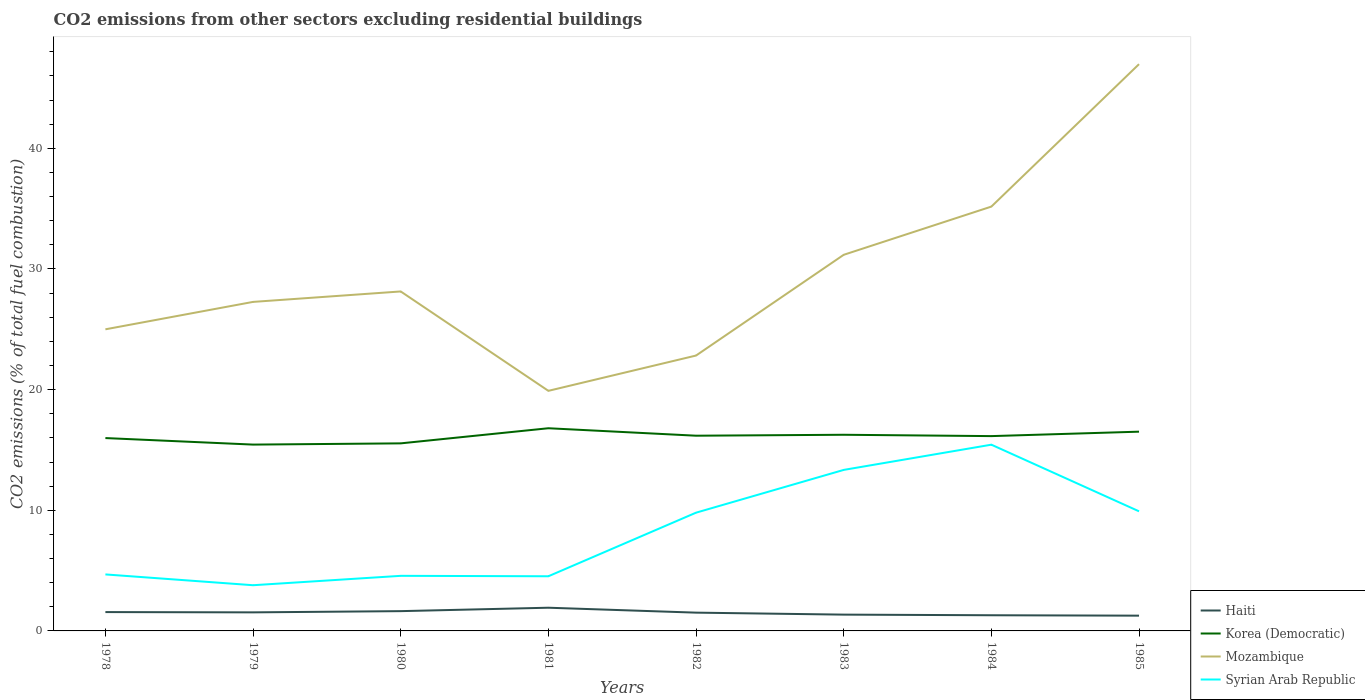How many different coloured lines are there?
Make the answer very short. 4. Across all years, what is the maximum total CO2 emitted in Syrian Arab Republic?
Give a very brief answer. 3.79. In which year was the total CO2 emitted in Korea (Democratic) maximum?
Give a very brief answer. 1979. What is the total total CO2 emitted in Korea (Democratic) in the graph?
Ensure brevity in your answer.  -0.16. What is the difference between the highest and the second highest total CO2 emitted in Korea (Democratic)?
Keep it short and to the point. 1.36. What is the difference between the highest and the lowest total CO2 emitted in Mozambique?
Your answer should be very brief. 3. How many lines are there?
Make the answer very short. 4. What is the difference between two consecutive major ticks on the Y-axis?
Your response must be concise. 10. Does the graph contain any zero values?
Give a very brief answer. No. Does the graph contain grids?
Keep it short and to the point. No. Where does the legend appear in the graph?
Provide a succinct answer. Bottom right. How many legend labels are there?
Your answer should be compact. 4. What is the title of the graph?
Keep it short and to the point. CO2 emissions from other sectors excluding residential buildings. What is the label or title of the X-axis?
Give a very brief answer. Years. What is the label or title of the Y-axis?
Offer a terse response. CO2 emissions (% of total fuel combustion). What is the CO2 emissions (% of total fuel combustion) of Haiti in 1978?
Keep it short and to the point. 1.56. What is the CO2 emissions (% of total fuel combustion) in Korea (Democratic) in 1978?
Offer a terse response. 15.99. What is the CO2 emissions (% of total fuel combustion) of Syrian Arab Republic in 1978?
Make the answer very short. 4.68. What is the CO2 emissions (% of total fuel combustion) in Haiti in 1979?
Make the answer very short. 1.54. What is the CO2 emissions (% of total fuel combustion) in Korea (Democratic) in 1979?
Your answer should be very brief. 15.44. What is the CO2 emissions (% of total fuel combustion) in Mozambique in 1979?
Offer a terse response. 27.27. What is the CO2 emissions (% of total fuel combustion) of Syrian Arab Republic in 1979?
Your response must be concise. 3.79. What is the CO2 emissions (% of total fuel combustion) of Haiti in 1980?
Keep it short and to the point. 1.64. What is the CO2 emissions (% of total fuel combustion) of Korea (Democratic) in 1980?
Your answer should be very brief. 15.55. What is the CO2 emissions (% of total fuel combustion) in Mozambique in 1980?
Provide a succinct answer. 28.14. What is the CO2 emissions (% of total fuel combustion) of Syrian Arab Republic in 1980?
Offer a terse response. 4.57. What is the CO2 emissions (% of total fuel combustion) of Haiti in 1981?
Your answer should be very brief. 1.92. What is the CO2 emissions (% of total fuel combustion) in Korea (Democratic) in 1981?
Your answer should be very brief. 16.8. What is the CO2 emissions (% of total fuel combustion) of Mozambique in 1981?
Give a very brief answer. 19.9. What is the CO2 emissions (% of total fuel combustion) of Syrian Arab Republic in 1981?
Your response must be concise. 4.53. What is the CO2 emissions (% of total fuel combustion) in Haiti in 1982?
Keep it short and to the point. 1.52. What is the CO2 emissions (% of total fuel combustion) of Korea (Democratic) in 1982?
Provide a short and direct response. 16.18. What is the CO2 emissions (% of total fuel combustion) in Mozambique in 1982?
Give a very brief answer. 22.83. What is the CO2 emissions (% of total fuel combustion) of Syrian Arab Republic in 1982?
Offer a terse response. 9.8. What is the CO2 emissions (% of total fuel combustion) in Haiti in 1983?
Keep it short and to the point. 1.35. What is the CO2 emissions (% of total fuel combustion) of Korea (Democratic) in 1983?
Make the answer very short. 16.26. What is the CO2 emissions (% of total fuel combustion) of Mozambique in 1983?
Your answer should be compact. 31.18. What is the CO2 emissions (% of total fuel combustion) of Syrian Arab Republic in 1983?
Offer a terse response. 13.35. What is the CO2 emissions (% of total fuel combustion) of Haiti in 1984?
Provide a succinct answer. 1.3. What is the CO2 emissions (% of total fuel combustion) of Korea (Democratic) in 1984?
Ensure brevity in your answer.  16.15. What is the CO2 emissions (% of total fuel combustion) of Mozambique in 1984?
Offer a very short reply. 35.17. What is the CO2 emissions (% of total fuel combustion) of Syrian Arab Republic in 1984?
Give a very brief answer. 15.44. What is the CO2 emissions (% of total fuel combustion) in Haiti in 1985?
Ensure brevity in your answer.  1.27. What is the CO2 emissions (% of total fuel combustion) of Korea (Democratic) in 1985?
Keep it short and to the point. 16.52. What is the CO2 emissions (% of total fuel combustion) of Mozambique in 1985?
Offer a terse response. 46.98. What is the CO2 emissions (% of total fuel combustion) of Syrian Arab Republic in 1985?
Keep it short and to the point. 9.91. Across all years, what is the maximum CO2 emissions (% of total fuel combustion) in Haiti?
Your answer should be very brief. 1.92. Across all years, what is the maximum CO2 emissions (% of total fuel combustion) of Korea (Democratic)?
Provide a short and direct response. 16.8. Across all years, what is the maximum CO2 emissions (% of total fuel combustion) in Mozambique?
Provide a short and direct response. 46.98. Across all years, what is the maximum CO2 emissions (% of total fuel combustion) in Syrian Arab Republic?
Offer a very short reply. 15.44. Across all years, what is the minimum CO2 emissions (% of total fuel combustion) in Haiti?
Your answer should be very brief. 1.27. Across all years, what is the minimum CO2 emissions (% of total fuel combustion) of Korea (Democratic)?
Your response must be concise. 15.44. Across all years, what is the minimum CO2 emissions (% of total fuel combustion) of Mozambique?
Your response must be concise. 19.9. Across all years, what is the minimum CO2 emissions (% of total fuel combustion) of Syrian Arab Republic?
Give a very brief answer. 3.79. What is the total CO2 emissions (% of total fuel combustion) of Haiti in the graph?
Give a very brief answer. 12.09. What is the total CO2 emissions (% of total fuel combustion) of Korea (Democratic) in the graph?
Offer a terse response. 128.88. What is the total CO2 emissions (% of total fuel combustion) of Mozambique in the graph?
Offer a very short reply. 236.47. What is the total CO2 emissions (% of total fuel combustion) in Syrian Arab Republic in the graph?
Keep it short and to the point. 66.07. What is the difference between the CO2 emissions (% of total fuel combustion) in Haiti in 1978 and that in 1979?
Give a very brief answer. 0.02. What is the difference between the CO2 emissions (% of total fuel combustion) of Korea (Democratic) in 1978 and that in 1979?
Keep it short and to the point. 0.54. What is the difference between the CO2 emissions (% of total fuel combustion) in Mozambique in 1978 and that in 1979?
Offer a terse response. -2.27. What is the difference between the CO2 emissions (% of total fuel combustion) of Syrian Arab Republic in 1978 and that in 1979?
Offer a very short reply. 0.9. What is the difference between the CO2 emissions (% of total fuel combustion) of Haiti in 1978 and that in 1980?
Give a very brief answer. -0.08. What is the difference between the CO2 emissions (% of total fuel combustion) in Korea (Democratic) in 1978 and that in 1980?
Ensure brevity in your answer.  0.44. What is the difference between the CO2 emissions (% of total fuel combustion) in Mozambique in 1978 and that in 1980?
Offer a terse response. -3.14. What is the difference between the CO2 emissions (% of total fuel combustion) of Syrian Arab Republic in 1978 and that in 1980?
Offer a very short reply. 0.12. What is the difference between the CO2 emissions (% of total fuel combustion) in Haiti in 1978 and that in 1981?
Provide a short and direct response. -0.36. What is the difference between the CO2 emissions (% of total fuel combustion) in Korea (Democratic) in 1978 and that in 1981?
Give a very brief answer. -0.81. What is the difference between the CO2 emissions (% of total fuel combustion) of Mozambique in 1978 and that in 1981?
Offer a very short reply. 5.1. What is the difference between the CO2 emissions (% of total fuel combustion) in Syrian Arab Republic in 1978 and that in 1981?
Offer a very short reply. 0.15. What is the difference between the CO2 emissions (% of total fuel combustion) of Haiti in 1978 and that in 1982?
Ensure brevity in your answer.  0.05. What is the difference between the CO2 emissions (% of total fuel combustion) in Korea (Democratic) in 1978 and that in 1982?
Provide a succinct answer. -0.2. What is the difference between the CO2 emissions (% of total fuel combustion) in Mozambique in 1978 and that in 1982?
Provide a succinct answer. 2.17. What is the difference between the CO2 emissions (% of total fuel combustion) in Syrian Arab Republic in 1978 and that in 1982?
Your answer should be compact. -5.12. What is the difference between the CO2 emissions (% of total fuel combustion) in Haiti in 1978 and that in 1983?
Offer a very short reply. 0.21. What is the difference between the CO2 emissions (% of total fuel combustion) of Korea (Democratic) in 1978 and that in 1983?
Offer a terse response. -0.27. What is the difference between the CO2 emissions (% of total fuel combustion) of Mozambique in 1978 and that in 1983?
Keep it short and to the point. -6.18. What is the difference between the CO2 emissions (% of total fuel combustion) in Syrian Arab Republic in 1978 and that in 1983?
Your answer should be compact. -8.66. What is the difference between the CO2 emissions (% of total fuel combustion) of Haiti in 1978 and that in 1984?
Your answer should be compact. 0.26. What is the difference between the CO2 emissions (% of total fuel combustion) in Korea (Democratic) in 1978 and that in 1984?
Offer a very short reply. -0.16. What is the difference between the CO2 emissions (% of total fuel combustion) in Mozambique in 1978 and that in 1984?
Your answer should be very brief. -10.17. What is the difference between the CO2 emissions (% of total fuel combustion) of Syrian Arab Republic in 1978 and that in 1984?
Offer a terse response. -10.75. What is the difference between the CO2 emissions (% of total fuel combustion) of Haiti in 1978 and that in 1985?
Make the answer very short. 0.3. What is the difference between the CO2 emissions (% of total fuel combustion) in Korea (Democratic) in 1978 and that in 1985?
Ensure brevity in your answer.  -0.53. What is the difference between the CO2 emissions (% of total fuel combustion) in Mozambique in 1978 and that in 1985?
Provide a succinct answer. -21.98. What is the difference between the CO2 emissions (% of total fuel combustion) in Syrian Arab Republic in 1978 and that in 1985?
Offer a very short reply. -5.23. What is the difference between the CO2 emissions (% of total fuel combustion) of Haiti in 1979 and that in 1980?
Make the answer very short. -0.1. What is the difference between the CO2 emissions (% of total fuel combustion) in Korea (Democratic) in 1979 and that in 1980?
Make the answer very short. -0.1. What is the difference between the CO2 emissions (% of total fuel combustion) of Mozambique in 1979 and that in 1980?
Your answer should be compact. -0.87. What is the difference between the CO2 emissions (% of total fuel combustion) in Syrian Arab Republic in 1979 and that in 1980?
Keep it short and to the point. -0.78. What is the difference between the CO2 emissions (% of total fuel combustion) of Haiti in 1979 and that in 1981?
Give a very brief answer. -0.38. What is the difference between the CO2 emissions (% of total fuel combustion) in Korea (Democratic) in 1979 and that in 1981?
Provide a succinct answer. -1.36. What is the difference between the CO2 emissions (% of total fuel combustion) of Mozambique in 1979 and that in 1981?
Your answer should be very brief. 7.37. What is the difference between the CO2 emissions (% of total fuel combustion) in Syrian Arab Republic in 1979 and that in 1981?
Offer a terse response. -0.74. What is the difference between the CO2 emissions (% of total fuel combustion) in Haiti in 1979 and that in 1982?
Offer a very short reply. 0.02. What is the difference between the CO2 emissions (% of total fuel combustion) of Korea (Democratic) in 1979 and that in 1982?
Make the answer very short. -0.74. What is the difference between the CO2 emissions (% of total fuel combustion) of Mozambique in 1979 and that in 1982?
Offer a terse response. 4.45. What is the difference between the CO2 emissions (% of total fuel combustion) in Syrian Arab Republic in 1979 and that in 1982?
Give a very brief answer. -6.01. What is the difference between the CO2 emissions (% of total fuel combustion) of Haiti in 1979 and that in 1983?
Provide a succinct answer. 0.19. What is the difference between the CO2 emissions (% of total fuel combustion) in Korea (Democratic) in 1979 and that in 1983?
Offer a very short reply. -0.82. What is the difference between the CO2 emissions (% of total fuel combustion) of Mozambique in 1979 and that in 1983?
Make the answer very short. -3.9. What is the difference between the CO2 emissions (% of total fuel combustion) of Syrian Arab Republic in 1979 and that in 1983?
Your answer should be very brief. -9.56. What is the difference between the CO2 emissions (% of total fuel combustion) of Haiti in 1979 and that in 1984?
Offer a terse response. 0.24. What is the difference between the CO2 emissions (% of total fuel combustion) in Korea (Democratic) in 1979 and that in 1984?
Make the answer very short. -0.7. What is the difference between the CO2 emissions (% of total fuel combustion) of Mozambique in 1979 and that in 1984?
Keep it short and to the point. -7.9. What is the difference between the CO2 emissions (% of total fuel combustion) of Syrian Arab Republic in 1979 and that in 1984?
Offer a very short reply. -11.65. What is the difference between the CO2 emissions (% of total fuel combustion) in Haiti in 1979 and that in 1985?
Offer a terse response. 0.27. What is the difference between the CO2 emissions (% of total fuel combustion) in Korea (Democratic) in 1979 and that in 1985?
Provide a succinct answer. -1.07. What is the difference between the CO2 emissions (% of total fuel combustion) in Mozambique in 1979 and that in 1985?
Offer a terse response. -19.71. What is the difference between the CO2 emissions (% of total fuel combustion) of Syrian Arab Republic in 1979 and that in 1985?
Offer a terse response. -6.13. What is the difference between the CO2 emissions (% of total fuel combustion) in Haiti in 1980 and that in 1981?
Make the answer very short. -0.28. What is the difference between the CO2 emissions (% of total fuel combustion) in Korea (Democratic) in 1980 and that in 1981?
Make the answer very short. -1.25. What is the difference between the CO2 emissions (% of total fuel combustion) in Mozambique in 1980 and that in 1981?
Ensure brevity in your answer.  8.24. What is the difference between the CO2 emissions (% of total fuel combustion) in Syrian Arab Republic in 1980 and that in 1981?
Keep it short and to the point. 0.04. What is the difference between the CO2 emissions (% of total fuel combustion) of Haiti in 1980 and that in 1982?
Make the answer very short. 0.12. What is the difference between the CO2 emissions (% of total fuel combustion) of Korea (Democratic) in 1980 and that in 1982?
Give a very brief answer. -0.63. What is the difference between the CO2 emissions (% of total fuel combustion) in Mozambique in 1980 and that in 1982?
Your answer should be very brief. 5.31. What is the difference between the CO2 emissions (% of total fuel combustion) of Syrian Arab Republic in 1980 and that in 1982?
Make the answer very short. -5.24. What is the difference between the CO2 emissions (% of total fuel combustion) of Haiti in 1980 and that in 1983?
Your answer should be very brief. 0.29. What is the difference between the CO2 emissions (% of total fuel combustion) in Korea (Democratic) in 1980 and that in 1983?
Provide a succinct answer. -0.71. What is the difference between the CO2 emissions (% of total fuel combustion) in Mozambique in 1980 and that in 1983?
Your answer should be compact. -3.04. What is the difference between the CO2 emissions (% of total fuel combustion) of Syrian Arab Republic in 1980 and that in 1983?
Provide a succinct answer. -8.78. What is the difference between the CO2 emissions (% of total fuel combustion) of Haiti in 1980 and that in 1984?
Offer a terse response. 0.34. What is the difference between the CO2 emissions (% of total fuel combustion) in Korea (Democratic) in 1980 and that in 1984?
Offer a terse response. -0.6. What is the difference between the CO2 emissions (% of total fuel combustion) of Mozambique in 1980 and that in 1984?
Your answer should be very brief. -7.03. What is the difference between the CO2 emissions (% of total fuel combustion) in Syrian Arab Republic in 1980 and that in 1984?
Give a very brief answer. -10.87. What is the difference between the CO2 emissions (% of total fuel combustion) in Haiti in 1980 and that in 1985?
Your response must be concise. 0.37. What is the difference between the CO2 emissions (% of total fuel combustion) of Korea (Democratic) in 1980 and that in 1985?
Give a very brief answer. -0.97. What is the difference between the CO2 emissions (% of total fuel combustion) in Mozambique in 1980 and that in 1985?
Keep it short and to the point. -18.84. What is the difference between the CO2 emissions (% of total fuel combustion) of Syrian Arab Republic in 1980 and that in 1985?
Offer a very short reply. -5.35. What is the difference between the CO2 emissions (% of total fuel combustion) in Haiti in 1981 and that in 1982?
Give a very brief answer. 0.41. What is the difference between the CO2 emissions (% of total fuel combustion) in Korea (Democratic) in 1981 and that in 1982?
Offer a terse response. 0.62. What is the difference between the CO2 emissions (% of total fuel combustion) in Mozambique in 1981 and that in 1982?
Offer a terse response. -2.93. What is the difference between the CO2 emissions (% of total fuel combustion) of Syrian Arab Republic in 1981 and that in 1982?
Give a very brief answer. -5.27. What is the difference between the CO2 emissions (% of total fuel combustion) of Haiti in 1981 and that in 1983?
Provide a succinct answer. 0.57. What is the difference between the CO2 emissions (% of total fuel combustion) in Korea (Democratic) in 1981 and that in 1983?
Provide a succinct answer. 0.54. What is the difference between the CO2 emissions (% of total fuel combustion) in Mozambique in 1981 and that in 1983?
Offer a terse response. -11.28. What is the difference between the CO2 emissions (% of total fuel combustion) in Syrian Arab Republic in 1981 and that in 1983?
Provide a short and direct response. -8.82. What is the difference between the CO2 emissions (% of total fuel combustion) of Haiti in 1981 and that in 1984?
Give a very brief answer. 0.62. What is the difference between the CO2 emissions (% of total fuel combustion) in Korea (Democratic) in 1981 and that in 1984?
Offer a very short reply. 0.65. What is the difference between the CO2 emissions (% of total fuel combustion) of Mozambique in 1981 and that in 1984?
Your answer should be very brief. -15.27. What is the difference between the CO2 emissions (% of total fuel combustion) of Syrian Arab Republic in 1981 and that in 1984?
Your answer should be very brief. -10.91. What is the difference between the CO2 emissions (% of total fuel combustion) of Haiti in 1981 and that in 1985?
Offer a terse response. 0.66. What is the difference between the CO2 emissions (% of total fuel combustion) of Korea (Democratic) in 1981 and that in 1985?
Your answer should be compact. 0.28. What is the difference between the CO2 emissions (% of total fuel combustion) of Mozambique in 1981 and that in 1985?
Provide a succinct answer. -27.08. What is the difference between the CO2 emissions (% of total fuel combustion) of Syrian Arab Republic in 1981 and that in 1985?
Offer a terse response. -5.38. What is the difference between the CO2 emissions (% of total fuel combustion) in Haiti in 1982 and that in 1983?
Offer a very short reply. 0.16. What is the difference between the CO2 emissions (% of total fuel combustion) of Korea (Democratic) in 1982 and that in 1983?
Ensure brevity in your answer.  -0.08. What is the difference between the CO2 emissions (% of total fuel combustion) in Mozambique in 1982 and that in 1983?
Provide a short and direct response. -8.35. What is the difference between the CO2 emissions (% of total fuel combustion) in Syrian Arab Republic in 1982 and that in 1983?
Give a very brief answer. -3.54. What is the difference between the CO2 emissions (% of total fuel combustion) of Haiti in 1982 and that in 1984?
Give a very brief answer. 0.22. What is the difference between the CO2 emissions (% of total fuel combustion) in Korea (Democratic) in 1982 and that in 1984?
Offer a terse response. 0.03. What is the difference between the CO2 emissions (% of total fuel combustion) of Mozambique in 1982 and that in 1984?
Ensure brevity in your answer.  -12.35. What is the difference between the CO2 emissions (% of total fuel combustion) of Syrian Arab Republic in 1982 and that in 1984?
Offer a terse response. -5.64. What is the difference between the CO2 emissions (% of total fuel combustion) in Haiti in 1982 and that in 1985?
Your response must be concise. 0.25. What is the difference between the CO2 emissions (% of total fuel combustion) in Korea (Democratic) in 1982 and that in 1985?
Provide a succinct answer. -0.33. What is the difference between the CO2 emissions (% of total fuel combustion) in Mozambique in 1982 and that in 1985?
Provide a succinct answer. -24.15. What is the difference between the CO2 emissions (% of total fuel combustion) in Syrian Arab Republic in 1982 and that in 1985?
Provide a succinct answer. -0.11. What is the difference between the CO2 emissions (% of total fuel combustion) in Haiti in 1983 and that in 1984?
Ensure brevity in your answer.  0.05. What is the difference between the CO2 emissions (% of total fuel combustion) of Korea (Democratic) in 1983 and that in 1984?
Keep it short and to the point. 0.11. What is the difference between the CO2 emissions (% of total fuel combustion) in Mozambique in 1983 and that in 1984?
Keep it short and to the point. -4. What is the difference between the CO2 emissions (% of total fuel combustion) in Syrian Arab Republic in 1983 and that in 1984?
Keep it short and to the point. -2.09. What is the difference between the CO2 emissions (% of total fuel combustion) of Haiti in 1983 and that in 1985?
Offer a terse response. 0.09. What is the difference between the CO2 emissions (% of total fuel combustion) of Korea (Democratic) in 1983 and that in 1985?
Your response must be concise. -0.26. What is the difference between the CO2 emissions (% of total fuel combustion) in Mozambique in 1983 and that in 1985?
Provide a succinct answer. -15.8. What is the difference between the CO2 emissions (% of total fuel combustion) of Syrian Arab Republic in 1983 and that in 1985?
Provide a succinct answer. 3.43. What is the difference between the CO2 emissions (% of total fuel combustion) of Haiti in 1984 and that in 1985?
Keep it short and to the point. 0.03. What is the difference between the CO2 emissions (% of total fuel combustion) of Korea (Democratic) in 1984 and that in 1985?
Keep it short and to the point. -0.37. What is the difference between the CO2 emissions (% of total fuel combustion) of Mozambique in 1984 and that in 1985?
Provide a succinct answer. -11.81. What is the difference between the CO2 emissions (% of total fuel combustion) in Syrian Arab Republic in 1984 and that in 1985?
Your answer should be compact. 5.52. What is the difference between the CO2 emissions (% of total fuel combustion) of Haiti in 1978 and the CO2 emissions (% of total fuel combustion) of Korea (Democratic) in 1979?
Give a very brief answer. -13.88. What is the difference between the CO2 emissions (% of total fuel combustion) of Haiti in 1978 and the CO2 emissions (% of total fuel combustion) of Mozambique in 1979?
Your response must be concise. -25.71. What is the difference between the CO2 emissions (% of total fuel combustion) in Haiti in 1978 and the CO2 emissions (% of total fuel combustion) in Syrian Arab Republic in 1979?
Give a very brief answer. -2.23. What is the difference between the CO2 emissions (% of total fuel combustion) of Korea (Democratic) in 1978 and the CO2 emissions (% of total fuel combustion) of Mozambique in 1979?
Your answer should be compact. -11.29. What is the difference between the CO2 emissions (% of total fuel combustion) of Korea (Democratic) in 1978 and the CO2 emissions (% of total fuel combustion) of Syrian Arab Republic in 1979?
Offer a very short reply. 12.2. What is the difference between the CO2 emissions (% of total fuel combustion) in Mozambique in 1978 and the CO2 emissions (% of total fuel combustion) in Syrian Arab Republic in 1979?
Offer a terse response. 21.21. What is the difference between the CO2 emissions (% of total fuel combustion) in Haiti in 1978 and the CO2 emissions (% of total fuel combustion) in Korea (Democratic) in 1980?
Ensure brevity in your answer.  -13.98. What is the difference between the CO2 emissions (% of total fuel combustion) in Haiti in 1978 and the CO2 emissions (% of total fuel combustion) in Mozambique in 1980?
Your response must be concise. -26.58. What is the difference between the CO2 emissions (% of total fuel combustion) of Haiti in 1978 and the CO2 emissions (% of total fuel combustion) of Syrian Arab Republic in 1980?
Give a very brief answer. -3. What is the difference between the CO2 emissions (% of total fuel combustion) in Korea (Democratic) in 1978 and the CO2 emissions (% of total fuel combustion) in Mozambique in 1980?
Provide a succinct answer. -12.15. What is the difference between the CO2 emissions (% of total fuel combustion) of Korea (Democratic) in 1978 and the CO2 emissions (% of total fuel combustion) of Syrian Arab Republic in 1980?
Keep it short and to the point. 11.42. What is the difference between the CO2 emissions (% of total fuel combustion) in Mozambique in 1978 and the CO2 emissions (% of total fuel combustion) in Syrian Arab Republic in 1980?
Give a very brief answer. 20.43. What is the difference between the CO2 emissions (% of total fuel combustion) of Haiti in 1978 and the CO2 emissions (% of total fuel combustion) of Korea (Democratic) in 1981?
Your answer should be compact. -15.24. What is the difference between the CO2 emissions (% of total fuel combustion) of Haiti in 1978 and the CO2 emissions (% of total fuel combustion) of Mozambique in 1981?
Offer a terse response. -18.34. What is the difference between the CO2 emissions (% of total fuel combustion) in Haiti in 1978 and the CO2 emissions (% of total fuel combustion) in Syrian Arab Republic in 1981?
Your response must be concise. -2.97. What is the difference between the CO2 emissions (% of total fuel combustion) in Korea (Democratic) in 1978 and the CO2 emissions (% of total fuel combustion) in Mozambique in 1981?
Provide a succinct answer. -3.91. What is the difference between the CO2 emissions (% of total fuel combustion) in Korea (Democratic) in 1978 and the CO2 emissions (% of total fuel combustion) in Syrian Arab Republic in 1981?
Your answer should be compact. 11.46. What is the difference between the CO2 emissions (% of total fuel combustion) in Mozambique in 1978 and the CO2 emissions (% of total fuel combustion) in Syrian Arab Republic in 1981?
Provide a short and direct response. 20.47. What is the difference between the CO2 emissions (% of total fuel combustion) in Haiti in 1978 and the CO2 emissions (% of total fuel combustion) in Korea (Democratic) in 1982?
Offer a very short reply. -14.62. What is the difference between the CO2 emissions (% of total fuel combustion) in Haiti in 1978 and the CO2 emissions (% of total fuel combustion) in Mozambique in 1982?
Your answer should be compact. -21.26. What is the difference between the CO2 emissions (% of total fuel combustion) of Haiti in 1978 and the CO2 emissions (% of total fuel combustion) of Syrian Arab Republic in 1982?
Your answer should be compact. -8.24. What is the difference between the CO2 emissions (% of total fuel combustion) of Korea (Democratic) in 1978 and the CO2 emissions (% of total fuel combustion) of Mozambique in 1982?
Your answer should be very brief. -6.84. What is the difference between the CO2 emissions (% of total fuel combustion) of Korea (Democratic) in 1978 and the CO2 emissions (% of total fuel combustion) of Syrian Arab Republic in 1982?
Offer a terse response. 6.18. What is the difference between the CO2 emissions (% of total fuel combustion) of Mozambique in 1978 and the CO2 emissions (% of total fuel combustion) of Syrian Arab Republic in 1982?
Ensure brevity in your answer.  15.2. What is the difference between the CO2 emissions (% of total fuel combustion) in Haiti in 1978 and the CO2 emissions (% of total fuel combustion) in Korea (Democratic) in 1983?
Give a very brief answer. -14.7. What is the difference between the CO2 emissions (% of total fuel combustion) of Haiti in 1978 and the CO2 emissions (% of total fuel combustion) of Mozambique in 1983?
Your answer should be very brief. -29.61. What is the difference between the CO2 emissions (% of total fuel combustion) in Haiti in 1978 and the CO2 emissions (% of total fuel combustion) in Syrian Arab Republic in 1983?
Give a very brief answer. -11.78. What is the difference between the CO2 emissions (% of total fuel combustion) of Korea (Democratic) in 1978 and the CO2 emissions (% of total fuel combustion) of Mozambique in 1983?
Offer a very short reply. -15.19. What is the difference between the CO2 emissions (% of total fuel combustion) of Korea (Democratic) in 1978 and the CO2 emissions (% of total fuel combustion) of Syrian Arab Republic in 1983?
Provide a succinct answer. 2.64. What is the difference between the CO2 emissions (% of total fuel combustion) of Mozambique in 1978 and the CO2 emissions (% of total fuel combustion) of Syrian Arab Republic in 1983?
Your response must be concise. 11.65. What is the difference between the CO2 emissions (% of total fuel combustion) in Haiti in 1978 and the CO2 emissions (% of total fuel combustion) in Korea (Democratic) in 1984?
Ensure brevity in your answer.  -14.59. What is the difference between the CO2 emissions (% of total fuel combustion) in Haiti in 1978 and the CO2 emissions (% of total fuel combustion) in Mozambique in 1984?
Your response must be concise. -33.61. What is the difference between the CO2 emissions (% of total fuel combustion) in Haiti in 1978 and the CO2 emissions (% of total fuel combustion) in Syrian Arab Republic in 1984?
Ensure brevity in your answer.  -13.87. What is the difference between the CO2 emissions (% of total fuel combustion) of Korea (Democratic) in 1978 and the CO2 emissions (% of total fuel combustion) of Mozambique in 1984?
Make the answer very short. -19.19. What is the difference between the CO2 emissions (% of total fuel combustion) in Korea (Democratic) in 1978 and the CO2 emissions (% of total fuel combustion) in Syrian Arab Republic in 1984?
Give a very brief answer. 0.55. What is the difference between the CO2 emissions (% of total fuel combustion) of Mozambique in 1978 and the CO2 emissions (% of total fuel combustion) of Syrian Arab Republic in 1984?
Provide a short and direct response. 9.56. What is the difference between the CO2 emissions (% of total fuel combustion) of Haiti in 1978 and the CO2 emissions (% of total fuel combustion) of Korea (Democratic) in 1985?
Ensure brevity in your answer.  -14.95. What is the difference between the CO2 emissions (% of total fuel combustion) in Haiti in 1978 and the CO2 emissions (% of total fuel combustion) in Mozambique in 1985?
Provide a succinct answer. -45.42. What is the difference between the CO2 emissions (% of total fuel combustion) of Haiti in 1978 and the CO2 emissions (% of total fuel combustion) of Syrian Arab Republic in 1985?
Ensure brevity in your answer.  -8.35. What is the difference between the CO2 emissions (% of total fuel combustion) in Korea (Democratic) in 1978 and the CO2 emissions (% of total fuel combustion) in Mozambique in 1985?
Make the answer very short. -30.99. What is the difference between the CO2 emissions (% of total fuel combustion) in Korea (Democratic) in 1978 and the CO2 emissions (% of total fuel combustion) in Syrian Arab Republic in 1985?
Your answer should be very brief. 6.07. What is the difference between the CO2 emissions (% of total fuel combustion) in Mozambique in 1978 and the CO2 emissions (% of total fuel combustion) in Syrian Arab Republic in 1985?
Offer a very short reply. 15.09. What is the difference between the CO2 emissions (% of total fuel combustion) in Haiti in 1979 and the CO2 emissions (% of total fuel combustion) in Korea (Democratic) in 1980?
Keep it short and to the point. -14.01. What is the difference between the CO2 emissions (% of total fuel combustion) of Haiti in 1979 and the CO2 emissions (% of total fuel combustion) of Mozambique in 1980?
Make the answer very short. -26.6. What is the difference between the CO2 emissions (% of total fuel combustion) in Haiti in 1979 and the CO2 emissions (% of total fuel combustion) in Syrian Arab Republic in 1980?
Provide a short and direct response. -3.03. What is the difference between the CO2 emissions (% of total fuel combustion) in Korea (Democratic) in 1979 and the CO2 emissions (% of total fuel combustion) in Mozambique in 1980?
Keep it short and to the point. -12.69. What is the difference between the CO2 emissions (% of total fuel combustion) of Korea (Democratic) in 1979 and the CO2 emissions (% of total fuel combustion) of Syrian Arab Republic in 1980?
Offer a very short reply. 10.88. What is the difference between the CO2 emissions (% of total fuel combustion) in Mozambique in 1979 and the CO2 emissions (% of total fuel combustion) in Syrian Arab Republic in 1980?
Your answer should be compact. 22.71. What is the difference between the CO2 emissions (% of total fuel combustion) of Haiti in 1979 and the CO2 emissions (% of total fuel combustion) of Korea (Democratic) in 1981?
Offer a terse response. -15.26. What is the difference between the CO2 emissions (% of total fuel combustion) in Haiti in 1979 and the CO2 emissions (% of total fuel combustion) in Mozambique in 1981?
Your answer should be very brief. -18.36. What is the difference between the CO2 emissions (% of total fuel combustion) of Haiti in 1979 and the CO2 emissions (% of total fuel combustion) of Syrian Arab Republic in 1981?
Keep it short and to the point. -2.99. What is the difference between the CO2 emissions (% of total fuel combustion) in Korea (Democratic) in 1979 and the CO2 emissions (% of total fuel combustion) in Mozambique in 1981?
Your answer should be compact. -4.46. What is the difference between the CO2 emissions (% of total fuel combustion) of Korea (Democratic) in 1979 and the CO2 emissions (% of total fuel combustion) of Syrian Arab Republic in 1981?
Your answer should be compact. 10.91. What is the difference between the CO2 emissions (% of total fuel combustion) in Mozambique in 1979 and the CO2 emissions (% of total fuel combustion) in Syrian Arab Republic in 1981?
Your answer should be compact. 22.74. What is the difference between the CO2 emissions (% of total fuel combustion) in Haiti in 1979 and the CO2 emissions (% of total fuel combustion) in Korea (Democratic) in 1982?
Your answer should be very brief. -14.64. What is the difference between the CO2 emissions (% of total fuel combustion) of Haiti in 1979 and the CO2 emissions (% of total fuel combustion) of Mozambique in 1982?
Provide a short and direct response. -21.29. What is the difference between the CO2 emissions (% of total fuel combustion) of Haiti in 1979 and the CO2 emissions (% of total fuel combustion) of Syrian Arab Republic in 1982?
Provide a succinct answer. -8.26. What is the difference between the CO2 emissions (% of total fuel combustion) in Korea (Democratic) in 1979 and the CO2 emissions (% of total fuel combustion) in Mozambique in 1982?
Keep it short and to the point. -7.38. What is the difference between the CO2 emissions (% of total fuel combustion) of Korea (Democratic) in 1979 and the CO2 emissions (% of total fuel combustion) of Syrian Arab Republic in 1982?
Your answer should be compact. 5.64. What is the difference between the CO2 emissions (% of total fuel combustion) of Mozambique in 1979 and the CO2 emissions (% of total fuel combustion) of Syrian Arab Republic in 1982?
Your answer should be very brief. 17.47. What is the difference between the CO2 emissions (% of total fuel combustion) in Haiti in 1979 and the CO2 emissions (% of total fuel combustion) in Korea (Democratic) in 1983?
Provide a succinct answer. -14.72. What is the difference between the CO2 emissions (% of total fuel combustion) of Haiti in 1979 and the CO2 emissions (% of total fuel combustion) of Mozambique in 1983?
Your answer should be compact. -29.64. What is the difference between the CO2 emissions (% of total fuel combustion) of Haiti in 1979 and the CO2 emissions (% of total fuel combustion) of Syrian Arab Republic in 1983?
Your response must be concise. -11.81. What is the difference between the CO2 emissions (% of total fuel combustion) in Korea (Democratic) in 1979 and the CO2 emissions (% of total fuel combustion) in Mozambique in 1983?
Ensure brevity in your answer.  -15.73. What is the difference between the CO2 emissions (% of total fuel combustion) in Korea (Democratic) in 1979 and the CO2 emissions (% of total fuel combustion) in Syrian Arab Republic in 1983?
Make the answer very short. 2.1. What is the difference between the CO2 emissions (% of total fuel combustion) of Mozambique in 1979 and the CO2 emissions (% of total fuel combustion) of Syrian Arab Republic in 1983?
Make the answer very short. 13.93. What is the difference between the CO2 emissions (% of total fuel combustion) in Haiti in 1979 and the CO2 emissions (% of total fuel combustion) in Korea (Democratic) in 1984?
Provide a succinct answer. -14.61. What is the difference between the CO2 emissions (% of total fuel combustion) of Haiti in 1979 and the CO2 emissions (% of total fuel combustion) of Mozambique in 1984?
Keep it short and to the point. -33.63. What is the difference between the CO2 emissions (% of total fuel combustion) in Haiti in 1979 and the CO2 emissions (% of total fuel combustion) in Syrian Arab Republic in 1984?
Offer a very short reply. -13.9. What is the difference between the CO2 emissions (% of total fuel combustion) in Korea (Democratic) in 1979 and the CO2 emissions (% of total fuel combustion) in Mozambique in 1984?
Provide a short and direct response. -19.73. What is the difference between the CO2 emissions (% of total fuel combustion) of Korea (Democratic) in 1979 and the CO2 emissions (% of total fuel combustion) of Syrian Arab Republic in 1984?
Offer a very short reply. 0.01. What is the difference between the CO2 emissions (% of total fuel combustion) in Mozambique in 1979 and the CO2 emissions (% of total fuel combustion) in Syrian Arab Republic in 1984?
Your answer should be compact. 11.84. What is the difference between the CO2 emissions (% of total fuel combustion) in Haiti in 1979 and the CO2 emissions (% of total fuel combustion) in Korea (Democratic) in 1985?
Your answer should be compact. -14.98. What is the difference between the CO2 emissions (% of total fuel combustion) in Haiti in 1979 and the CO2 emissions (% of total fuel combustion) in Mozambique in 1985?
Make the answer very short. -45.44. What is the difference between the CO2 emissions (% of total fuel combustion) of Haiti in 1979 and the CO2 emissions (% of total fuel combustion) of Syrian Arab Republic in 1985?
Give a very brief answer. -8.38. What is the difference between the CO2 emissions (% of total fuel combustion) of Korea (Democratic) in 1979 and the CO2 emissions (% of total fuel combustion) of Mozambique in 1985?
Offer a terse response. -31.54. What is the difference between the CO2 emissions (% of total fuel combustion) of Korea (Democratic) in 1979 and the CO2 emissions (% of total fuel combustion) of Syrian Arab Republic in 1985?
Your answer should be very brief. 5.53. What is the difference between the CO2 emissions (% of total fuel combustion) of Mozambique in 1979 and the CO2 emissions (% of total fuel combustion) of Syrian Arab Republic in 1985?
Offer a very short reply. 17.36. What is the difference between the CO2 emissions (% of total fuel combustion) in Haiti in 1980 and the CO2 emissions (% of total fuel combustion) in Korea (Democratic) in 1981?
Your answer should be compact. -15.16. What is the difference between the CO2 emissions (% of total fuel combustion) of Haiti in 1980 and the CO2 emissions (% of total fuel combustion) of Mozambique in 1981?
Make the answer very short. -18.26. What is the difference between the CO2 emissions (% of total fuel combustion) of Haiti in 1980 and the CO2 emissions (% of total fuel combustion) of Syrian Arab Republic in 1981?
Offer a terse response. -2.89. What is the difference between the CO2 emissions (% of total fuel combustion) of Korea (Democratic) in 1980 and the CO2 emissions (% of total fuel combustion) of Mozambique in 1981?
Your answer should be compact. -4.35. What is the difference between the CO2 emissions (% of total fuel combustion) in Korea (Democratic) in 1980 and the CO2 emissions (% of total fuel combustion) in Syrian Arab Republic in 1981?
Provide a short and direct response. 11.02. What is the difference between the CO2 emissions (% of total fuel combustion) of Mozambique in 1980 and the CO2 emissions (% of total fuel combustion) of Syrian Arab Republic in 1981?
Offer a very short reply. 23.61. What is the difference between the CO2 emissions (% of total fuel combustion) in Haiti in 1980 and the CO2 emissions (% of total fuel combustion) in Korea (Democratic) in 1982?
Your answer should be compact. -14.54. What is the difference between the CO2 emissions (% of total fuel combustion) of Haiti in 1980 and the CO2 emissions (% of total fuel combustion) of Mozambique in 1982?
Ensure brevity in your answer.  -21.19. What is the difference between the CO2 emissions (% of total fuel combustion) in Haiti in 1980 and the CO2 emissions (% of total fuel combustion) in Syrian Arab Republic in 1982?
Offer a very short reply. -8.16. What is the difference between the CO2 emissions (% of total fuel combustion) in Korea (Democratic) in 1980 and the CO2 emissions (% of total fuel combustion) in Mozambique in 1982?
Provide a short and direct response. -7.28. What is the difference between the CO2 emissions (% of total fuel combustion) in Korea (Democratic) in 1980 and the CO2 emissions (% of total fuel combustion) in Syrian Arab Republic in 1982?
Your response must be concise. 5.75. What is the difference between the CO2 emissions (% of total fuel combustion) of Mozambique in 1980 and the CO2 emissions (% of total fuel combustion) of Syrian Arab Republic in 1982?
Your response must be concise. 18.34. What is the difference between the CO2 emissions (% of total fuel combustion) of Haiti in 1980 and the CO2 emissions (% of total fuel combustion) of Korea (Democratic) in 1983?
Offer a very short reply. -14.62. What is the difference between the CO2 emissions (% of total fuel combustion) of Haiti in 1980 and the CO2 emissions (% of total fuel combustion) of Mozambique in 1983?
Your answer should be compact. -29.54. What is the difference between the CO2 emissions (% of total fuel combustion) of Haiti in 1980 and the CO2 emissions (% of total fuel combustion) of Syrian Arab Republic in 1983?
Your response must be concise. -11.71. What is the difference between the CO2 emissions (% of total fuel combustion) in Korea (Democratic) in 1980 and the CO2 emissions (% of total fuel combustion) in Mozambique in 1983?
Provide a short and direct response. -15.63. What is the difference between the CO2 emissions (% of total fuel combustion) of Korea (Democratic) in 1980 and the CO2 emissions (% of total fuel combustion) of Syrian Arab Republic in 1983?
Give a very brief answer. 2.2. What is the difference between the CO2 emissions (% of total fuel combustion) in Mozambique in 1980 and the CO2 emissions (% of total fuel combustion) in Syrian Arab Republic in 1983?
Your response must be concise. 14.79. What is the difference between the CO2 emissions (% of total fuel combustion) of Haiti in 1980 and the CO2 emissions (% of total fuel combustion) of Korea (Democratic) in 1984?
Your response must be concise. -14.51. What is the difference between the CO2 emissions (% of total fuel combustion) of Haiti in 1980 and the CO2 emissions (% of total fuel combustion) of Mozambique in 1984?
Your answer should be compact. -33.53. What is the difference between the CO2 emissions (% of total fuel combustion) in Haiti in 1980 and the CO2 emissions (% of total fuel combustion) in Syrian Arab Republic in 1984?
Make the answer very short. -13.8. What is the difference between the CO2 emissions (% of total fuel combustion) in Korea (Democratic) in 1980 and the CO2 emissions (% of total fuel combustion) in Mozambique in 1984?
Provide a succinct answer. -19.63. What is the difference between the CO2 emissions (% of total fuel combustion) in Korea (Democratic) in 1980 and the CO2 emissions (% of total fuel combustion) in Syrian Arab Republic in 1984?
Your answer should be compact. 0.11. What is the difference between the CO2 emissions (% of total fuel combustion) in Mozambique in 1980 and the CO2 emissions (% of total fuel combustion) in Syrian Arab Republic in 1984?
Your answer should be compact. 12.7. What is the difference between the CO2 emissions (% of total fuel combustion) in Haiti in 1980 and the CO2 emissions (% of total fuel combustion) in Korea (Democratic) in 1985?
Provide a succinct answer. -14.88. What is the difference between the CO2 emissions (% of total fuel combustion) of Haiti in 1980 and the CO2 emissions (% of total fuel combustion) of Mozambique in 1985?
Offer a terse response. -45.34. What is the difference between the CO2 emissions (% of total fuel combustion) in Haiti in 1980 and the CO2 emissions (% of total fuel combustion) in Syrian Arab Republic in 1985?
Ensure brevity in your answer.  -8.28. What is the difference between the CO2 emissions (% of total fuel combustion) of Korea (Democratic) in 1980 and the CO2 emissions (% of total fuel combustion) of Mozambique in 1985?
Offer a very short reply. -31.43. What is the difference between the CO2 emissions (% of total fuel combustion) of Korea (Democratic) in 1980 and the CO2 emissions (% of total fuel combustion) of Syrian Arab Republic in 1985?
Your answer should be compact. 5.63. What is the difference between the CO2 emissions (% of total fuel combustion) of Mozambique in 1980 and the CO2 emissions (% of total fuel combustion) of Syrian Arab Republic in 1985?
Offer a terse response. 18.22. What is the difference between the CO2 emissions (% of total fuel combustion) in Haiti in 1981 and the CO2 emissions (% of total fuel combustion) in Korea (Democratic) in 1982?
Provide a short and direct response. -14.26. What is the difference between the CO2 emissions (% of total fuel combustion) in Haiti in 1981 and the CO2 emissions (% of total fuel combustion) in Mozambique in 1982?
Ensure brevity in your answer.  -20.9. What is the difference between the CO2 emissions (% of total fuel combustion) in Haiti in 1981 and the CO2 emissions (% of total fuel combustion) in Syrian Arab Republic in 1982?
Ensure brevity in your answer.  -7.88. What is the difference between the CO2 emissions (% of total fuel combustion) in Korea (Democratic) in 1981 and the CO2 emissions (% of total fuel combustion) in Mozambique in 1982?
Your answer should be very brief. -6.03. What is the difference between the CO2 emissions (% of total fuel combustion) of Korea (Democratic) in 1981 and the CO2 emissions (% of total fuel combustion) of Syrian Arab Republic in 1982?
Ensure brevity in your answer.  7. What is the difference between the CO2 emissions (% of total fuel combustion) in Mozambique in 1981 and the CO2 emissions (% of total fuel combustion) in Syrian Arab Republic in 1982?
Your response must be concise. 10.1. What is the difference between the CO2 emissions (% of total fuel combustion) of Haiti in 1981 and the CO2 emissions (% of total fuel combustion) of Korea (Democratic) in 1983?
Your answer should be compact. -14.34. What is the difference between the CO2 emissions (% of total fuel combustion) of Haiti in 1981 and the CO2 emissions (% of total fuel combustion) of Mozambique in 1983?
Offer a very short reply. -29.25. What is the difference between the CO2 emissions (% of total fuel combustion) of Haiti in 1981 and the CO2 emissions (% of total fuel combustion) of Syrian Arab Republic in 1983?
Give a very brief answer. -11.42. What is the difference between the CO2 emissions (% of total fuel combustion) in Korea (Democratic) in 1981 and the CO2 emissions (% of total fuel combustion) in Mozambique in 1983?
Your answer should be very brief. -14.38. What is the difference between the CO2 emissions (% of total fuel combustion) of Korea (Democratic) in 1981 and the CO2 emissions (% of total fuel combustion) of Syrian Arab Republic in 1983?
Provide a short and direct response. 3.45. What is the difference between the CO2 emissions (% of total fuel combustion) of Mozambique in 1981 and the CO2 emissions (% of total fuel combustion) of Syrian Arab Republic in 1983?
Offer a terse response. 6.55. What is the difference between the CO2 emissions (% of total fuel combustion) in Haiti in 1981 and the CO2 emissions (% of total fuel combustion) in Korea (Democratic) in 1984?
Provide a short and direct response. -14.22. What is the difference between the CO2 emissions (% of total fuel combustion) of Haiti in 1981 and the CO2 emissions (% of total fuel combustion) of Mozambique in 1984?
Your answer should be compact. -33.25. What is the difference between the CO2 emissions (% of total fuel combustion) of Haiti in 1981 and the CO2 emissions (% of total fuel combustion) of Syrian Arab Republic in 1984?
Give a very brief answer. -13.51. What is the difference between the CO2 emissions (% of total fuel combustion) in Korea (Democratic) in 1981 and the CO2 emissions (% of total fuel combustion) in Mozambique in 1984?
Offer a terse response. -18.37. What is the difference between the CO2 emissions (% of total fuel combustion) in Korea (Democratic) in 1981 and the CO2 emissions (% of total fuel combustion) in Syrian Arab Republic in 1984?
Keep it short and to the point. 1.36. What is the difference between the CO2 emissions (% of total fuel combustion) of Mozambique in 1981 and the CO2 emissions (% of total fuel combustion) of Syrian Arab Republic in 1984?
Offer a terse response. 4.46. What is the difference between the CO2 emissions (% of total fuel combustion) in Haiti in 1981 and the CO2 emissions (% of total fuel combustion) in Korea (Democratic) in 1985?
Your answer should be very brief. -14.59. What is the difference between the CO2 emissions (% of total fuel combustion) of Haiti in 1981 and the CO2 emissions (% of total fuel combustion) of Mozambique in 1985?
Keep it short and to the point. -45.06. What is the difference between the CO2 emissions (% of total fuel combustion) in Haiti in 1981 and the CO2 emissions (% of total fuel combustion) in Syrian Arab Republic in 1985?
Offer a very short reply. -7.99. What is the difference between the CO2 emissions (% of total fuel combustion) of Korea (Democratic) in 1981 and the CO2 emissions (% of total fuel combustion) of Mozambique in 1985?
Provide a short and direct response. -30.18. What is the difference between the CO2 emissions (% of total fuel combustion) of Korea (Democratic) in 1981 and the CO2 emissions (% of total fuel combustion) of Syrian Arab Republic in 1985?
Provide a short and direct response. 6.89. What is the difference between the CO2 emissions (% of total fuel combustion) in Mozambique in 1981 and the CO2 emissions (% of total fuel combustion) in Syrian Arab Republic in 1985?
Your answer should be compact. 9.99. What is the difference between the CO2 emissions (% of total fuel combustion) of Haiti in 1982 and the CO2 emissions (% of total fuel combustion) of Korea (Democratic) in 1983?
Your response must be concise. -14.74. What is the difference between the CO2 emissions (% of total fuel combustion) of Haiti in 1982 and the CO2 emissions (% of total fuel combustion) of Mozambique in 1983?
Your answer should be compact. -29.66. What is the difference between the CO2 emissions (% of total fuel combustion) of Haiti in 1982 and the CO2 emissions (% of total fuel combustion) of Syrian Arab Republic in 1983?
Your answer should be very brief. -11.83. What is the difference between the CO2 emissions (% of total fuel combustion) in Korea (Democratic) in 1982 and the CO2 emissions (% of total fuel combustion) in Mozambique in 1983?
Provide a short and direct response. -14.99. What is the difference between the CO2 emissions (% of total fuel combustion) in Korea (Democratic) in 1982 and the CO2 emissions (% of total fuel combustion) in Syrian Arab Republic in 1983?
Make the answer very short. 2.84. What is the difference between the CO2 emissions (% of total fuel combustion) of Mozambique in 1982 and the CO2 emissions (% of total fuel combustion) of Syrian Arab Republic in 1983?
Your answer should be very brief. 9.48. What is the difference between the CO2 emissions (% of total fuel combustion) of Haiti in 1982 and the CO2 emissions (% of total fuel combustion) of Korea (Democratic) in 1984?
Provide a short and direct response. -14.63. What is the difference between the CO2 emissions (% of total fuel combustion) of Haiti in 1982 and the CO2 emissions (% of total fuel combustion) of Mozambique in 1984?
Your answer should be very brief. -33.66. What is the difference between the CO2 emissions (% of total fuel combustion) in Haiti in 1982 and the CO2 emissions (% of total fuel combustion) in Syrian Arab Republic in 1984?
Keep it short and to the point. -13.92. What is the difference between the CO2 emissions (% of total fuel combustion) of Korea (Democratic) in 1982 and the CO2 emissions (% of total fuel combustion) of Mozambique in 1984?
Your answer should be very brief. -18.99. What is the difference between the CO2 emissions (% of total fuel combustion) of Korea (Democratic) in 1982 and the CO2 emissions (% of total fuel combustion) of Syrian Arab Republic in 1984?
Offer a terse response. 0.74. What is the difference between the CO2 emissions (% of total fuel combustion) in Mozambique in 1982 and the CO2 emissions (% of total fuel combustion) in Syrian Arab Republic in 1984?
Provide a short and direct response. 7.39. What is the difference between the CO2 emissions (% of total fuel combustion) of Haiti in 1982 and the CO2 emissions (% of total fuel combustion) of Korea (Democratic) in 1985?
Your answer should be compact. -15. What is the difference between the CO2 emissions (% of total fuel combustion) in Haiti in 1982 and the CO2 emissions (% of total fuel combustion) in Mozambique in 1985?
Offer a very short reply. -45.46. What is the difference between the CO2 emissions (% of total fuel combustion) in Haiti in 1982 and the CO2 emissions (% of total fuel combustion) in Syrian Arab Republic in 1985?
Make the answer very short. -8.4. What is the difference between the CO2 emissions (% of total fuel combustion) of Korea (Democratic) in 1982 and the CO2 emissions (% of total fuel combustion) of Mozambique in 1985?
Your answer should be very brief. -30.8. What is the difference between the CO2 emissions (% of total fuel combustion) of Korea (Democratic) in 1982 and the CO2 emissions (% of total fuel combustion) of Syrian Arab Republic in 1985?
Your answer should be compact. 6.27. What is the difference between the CO2 emissions (% of total fuel combustion) in Mozambique in 1982 and the CO2 emissions (% of total fuel combustion) in Syrian Arab Republic in 1985?
Ensure brevity in your answer.  12.91. What is the difference between the CO2 emissions (% of total fuel combustion) of Haiti in 1983 and the CO2 emissions (% of total fuel combustion) of Korea (Democratic) in 1984?
Keep it short and to the point. -14.8. What is the difference between the CO2 emissions (% of total fuel combustion) in Haiti in 1983 and the CO2 emissions (% of total fuel combustion) in Mozambique in 1984?
Give a very brief answer. -33.82. What is the difference between the CO2 emissions (% of total fuel combustion) of Haiti in 1983 and the CO2 emissions (% of total fuel combustion) of Syrian Arab Republic in 1984?
Make the answer very short. -14.09. What is the difference between the CO2 emissions (% of total fuel combustion) in Korea (Democratic) in 1983 and the CO2 emissions (% of total fuel combustion) in Mozambique in 1984?
Your response must be concise. -18.91. What is the difference between the CO2 emissions (% of total fuel combustion) of Korea (Democratic) in 1983 and the CO2 emissions (% of total fuel combustion) of Syrian Arab Republic in 1984?
Your answer should be very brief. 0.82. What is the difference between the CO2 emissions (% of total fuel combustion) of Mozambique in 1983 and the CO2 emissions (% of total fuel combustion) of Syrian Arab Republic in 1984?
Make the answer very short. 15.74. What is the difference between the CO2 emissions (% of total fuel combustion) in Haiti in 1983 and the CO2 emissions (% of total fuel combustion) in Korea (Democratic) in 1985?
Make the answer very short. -15.16. What is the difference between the CO2 emissions (% of total fuel combustion) in Haiti in 1983 and the CO2 emissions (% of total fuel combustion) in Mozambique in 1985?
Give a very brief answer. -45.63. What is the difference between the CO2 emissions (% of total fuel combustion) of Haiti in 1983 and the CO2 emissions (% of total fuel combustion) of Syrian Arab Republic in 1985?
Your answer should be very brief. -8.56. What is the difference between the CO2 emissions (% of total fuel combustion) of Korea (Democratic) in 1983 and the CO2 emissions (% of total fuel combustion) of Mozambique in 1985?
Your answer should be compact. -30.72. What is the difference between the CO2 emissions (% of total fuel combustion) in Korea (Democratic) in 1983 and the CO2 emissions (% of total fuel combustion) in Syrian Arab Republic in 1985?
Your answer should be very brief. 6.34. What is the difference between the CO2 emissions (% of total fuel combustion) in Mozambique in 1983 and the CO2 emissions (% of total fuel combustion) in Syrian Arab Republic in 1985?
Offer a terse response. 21.26. What is the difference between the CO2 emissions (% of total fuel combustion) of Haiti in 1984 and the CO2 emissions (% of total fuel combustion) of Korea (Democratic) in 1985?
Your answer should be very brief. -15.22. What is the difference between the CO2 emissions (% of total fuel combustion) of Haiti in 1984 and the CO2 emissions (% of total fuel combustion) of Mozambique in 1985?
Ensure brevity in your answer.  -45.68. What is the difference between the CO2 emissions (% of total fuel combustion) in Haiti in 1984 and the CO2 emissions (% of total fuel combustion) in Syrian Arab Republic in 1985?
Give a very brief answer. -8.62. What is the difference between the CO2 emissions (% of total fuel combustion) in Korea (Democratic) in 1984 and the CO2 emissions (% of total fuel combustion) in Mozambique in 1985?
Your answer should be compact. -30.83. What is the difference between the CO2 emissions (% of total fuel combustion) of Korea (Democratic) in 1984 and the CO2 emissions (% of total fuel combustion) of Syrian Arab Republic in 1985?
Ensure brevity in your answer.  6.23. What is the difference between the CO2 emissions (% of total fuel combustion) of Mozambique in 1984 and the CO2 emissions (% of total fuel combustion) of Syrian Arab Republic in 1985?
Give a very brief answer. 25.26. What is the average CO2 emissions (% of total fuel combustion) of Haiti per year?
Ensure brevity in your answer.  1.51. What is the average CO2 emissions (% of total fuel combustion) in Korea (Democratic) per year?
Give a very brief answer. 16.11. What is the average CO2 emissions (% of total fuel combustion) in Mozambique per year?
Provide a succinct answer. 29.56. What is the average CO2 emissions (% of total fuel combustion) of Syrian Arab Republic per year?
Offer a terse response. 8.26. In the year 1978, what is the difference between the CO2 emissions (% of total fuel combustion) in Haiti and CO2 emissions (% of total fuel combustion) in Korea (Democratic)?
Make the answer very short. -14.42. In the year 1978, what is the difference between the CO2 emissions (% of total fuel combustion) in Haiti and CO2 emissions (% of total fuel combustion) in Mozambique?
Provide a succinct answer. -23.44. In the year 1978, what is the difference between the CO2 emissions (% of total fuel combustion) in Haiti and CO2 emissions (% of total fuel combustion) in Syrian Arab Republic?
Offer a very short reply. -3.12. In the year 1978, what is the difference between the CO2 emissions (% of total fuel combustion) in Korea (Democratic) and CO2 emissions (% of total fuel combustion) in Mozambique?
Make the answer very short. -9.01. In the year 1978, what is the difference between the CO2 emissions (% of total fuel combustion) in Korea (Democratic) and CO2 emissions (% of total fuel combustion) in Syrian Arab Republic?
Provide a short and direct response. 11.3. In the year 1978, what is the difference between the CO2 emissions (% of total fuel combustion) in Mozambique and CO2 emissions (% of total fuel combustion) in Syrian Arab Republic?
Your response must be concise. 20.32. In the year 1979, what is the difference between the CO2 emissions (% of total fuel combustion) in Haiti and CO2 emissions (% of total fuel combustion) in Korea (Democratic)?
Provide a succinct answer. -13.91. In the year 1979, what is the difference between the CO2 emissions (% of total fuel combustion) in Haiti and CO2 emissions (% of total fuel combustion) in Mozambique?
Your answer should be very brief. -25.73. In the year 1979, what is the difference between the CO2 emissions (% of total fuel combustion) in Haiti and CO2 emissions (% of total fuel combustion) in Syrian Arab Republic?
Your answer should be very brief. -2.25. In the year 1979, what is the difference between the CO2 emissions (% of total fuel combustion) of Korea (Democratic) and CO2 emissions (% of total fuel combustion) of Mozambique?
Ensure brevity in your answer.  -11.83. In the year 1979, what is the difference between the CO2 emissions (% of total fuel combustion) in Korea (Democratic) and CO2 emissions (% of total fuel combustion) in Syrian Arab Republic?
Make the answer very short. 11.66. In the year 1979, what is the difference between the CO2 emissions (% of total fuel combustion) in Mozambique and CO2 emissions (% of total fuel combustion) in Syrian Arab Republic?
Offer a terse response. 23.48. In the year 1980, what is the difference between the CO2 emissions (% of total fuel combustion) in Haiti and CO2 emissions (% of total fuel combustion) in Korea (Democratic)?
Ensure brevity in your answer.  -13.91. In the year 1980, what is the difference between the CO2 emissions (% of total fuel combustion) in Haiti and CO2 emissions (% of total fuel combustion) in Mozambique?
Give a very brief answer. -26.5. In the year 1980, what is the difference between the CO2 emissions (% of total fuel combustion) of Haiti and CO2 emissions (% of total fuel combustion) of Syrian Arab Republic?
Offer a very short reply. -2.93. In the year 1980, what is the difference between the CO2 emissions (% of total fuel combustion) of Korea (Democratic) and CO2 emissions (% of total fuel combustion) of Mozambique?
Your response must be concise. -12.59. In the year 1980, what is the difference between the CO2 emissions (% of total fuel combustion) of Korea (Democratic) and CO2 emissions (% of total fuel combustion) of Syrian Arab Republic?
Keep it short and to the point. 10.98. In the year 1980, what is the difference between the CO2 emissions (% of total fuel combustion) of Mozambique and CO2 emissions (% of total fuel combustion) of Syrian Arab Republic?
Your response must be concise. 23.57. In the year 1981, what is the difference between the CO2 emissions (% of total fuel combustion) in Haiti and CO2 emissions (% of total fuel combustion) in Korea (Democratic)?
Ensure brevity in your answer.  -14.88. In the year 1981, what is the difference between the CO2 emissions (% of total fuel combustion) of Haiti and CO2 emissions (% of total fuel combustion) of Mozambique?
Provide a short and direct response. -17.98. In the year 1981, what is the difference between the CO2 emissions (% of total fuel combustion) in Haiti and CO2 emissions (% of total fuel combustion) in Syrian Arab Republic?
Give a very brief answer. -2.61. In the year 1981, what is the difference between the CO2 emissions (% of total fuel combustion) of Korea (Democratic) and CO2 emissions (% of total fuel combustion) of Mozambique?
Offer a terse response. -3.1. In the year 1981, what is the difference between the CO2 emissions (% of total fuel combustion) in Korea (Democratic) and CO2 emissions (% of total fuel combustion) in Syrian Arab Republic?
Your answer should be compact. 12.27. In the year 1981, what is the difference between the CO2 emissions (% of total fuel combustion) of Mozambique and CO2 emissions (% of total fuel combustion) of Syrian Arab Republic?
Make the answer very short. 15.37. In the year 1982, what is the difference between the CO2 emissions (% of total fuel combustion) of Haiti and CO2 emissions (% of total fuel combustion) of Korea (Democratic)?
Offer a terse response. -14.67. In the year 1982, what is the difference between the CO2 emissions (% of total fuel combustion) in Haiti and CO2 emissions (% of total fuel combustion) in Mozambique?
Give a very brief answer. -21.31. In the year 1982, what is the difference between the CO2 emissions (% of total fuel combustion) of Haiti and CO2 emissions (% of total fuel combustion) of Syrian Arab Republic?
Offer a terse response. -8.29. In the year 1982, what is the difference between the CO2 emissions (% of total fuel combustion) of Korea (Democratic) and CO2 emissions (% of total fuel combustion) of Mozambique?
Ensure brevity in your answer.  -6.64. In the year 1982, what is the difference between the CO2 emissions (% of total fuel combustion) in Korea (Democratic) and CO2 emissions (% of total fuel combustion) in Syrian Arab Republic?
Provide a short and direct response. 6.38. In the year 1982, what is the difference between the CO2 emissions (% of total fuel combustion) of Mozambique and CO2 emissions (% of total fuel combustion) of Syrian Arab Republic?
Offer a terse response. 13.02. In the year 1983, what is the difference between the CO2 emissions (% of total fuel combustion) of Haiti and CO2 emissions (% of total fuel combustion) of Korea (Democratic)?
Offer a terse response. -14.91. In the year 1983, what is the difference between the CO2 emissions (% of total fuel combustion) of Haiti and CO2 emissions (% of total fuel combustion) of Mozambique?
Keep it short and to the point. -29.83. In the year 1983, what is the difference between the CO2 emissions (% of total fuel combustion) of Haiti and CO2 emissions (% of total fuel combustion) of Syrian Arab Republic?
Give a very brief answer. -11.99. In the year 1983, what is the difference between the CO2 emissions (% of total fuel combustion) in Korea (Democratic) and CO2 emissions (% of total fuel combustion) in Mozambique?
Offer a terse response. -14.92. In the year 1983, what is the difference between the CO2 emissions (% of total fuel combustion) of Korea (Democratic) and CO2 emissions (% of total fuel combustion) of Syrian Arab Republic?
Provide a succinct answer. 2.91. In the year 1983, what is the difference between the CO2 emissions (% of total fuel combustion) of Mozambique and CO2 emissions (% of total fuel combustion) of Syrian Arab Republic?
Offer a very short reply. 17.83. In the year 1984, what is the difference between the CO2 emissions (% of total fuel combustion) in Haiti and CO2 emissions (% of total fuel combustion) in Korea (Democratic)?
Your answer should be compact. -14.85. In the year 1984, what is the difference between the CO2 emissions (% of total fuel combustion) of Haiti and CO2 emissions (% of total fuel combustion) of Mozambique?
Offer a very short reply. -33.87. In the year 1984, what is the difference between the CO2 emissions (% of total fuel combustion) of Haiti and CO2 emissions (% of total fuel combustion) of Syrian Arab Republic?
Your answer should be compact. -14.14. In the year 1984, what is the difference between the CO2 emissions (% of total fuel combustion) of Korea (Democratic) and CO2 emissions (% of total fuel combustion) of Mozambique?
Make the answer very short. -19.02. In the year 1984, what is the difference between the CO2 emissions (% of total fuel combustion) in Korea (Democratic) and CO2 emissions (% of total fuel combustion) in Syrian Arab Republic?
Offer a terse response. 0.71. In the year 1984, what is the difference between the CO2 emissions (% of total fuel combustion) in Mozambique and CO2 emissions (% of total fuel combustion) in Syrian Arab Republic?
Give a very brief answer. 19.73. In the year 1985, what is the difference between the CO2 emissions (% of total fuel combustion) of Haiti and CO2 emissions (% of total fuel combustion) of Korea (Democratic)?
Keep it short and to the point. -15.25. In the year 1985, what is the difference between the CO2 emissions (% of total fuel combustion) in Haiti and CO2 emissions (% of total fuel combustion) in Mozambique?
Your answer should be very brief. -45.71. In the year 1985, what is the difference between the CO2 emissions (% of total fuel combustion) of Haiti and CO2 emissions (% of total fuel combustion) of Syrian Arab Republic?
Your answer should be very brief. -8.65. In the year 1985, what is the difference between the CO2 emissions (% of total fuel combustion) in Korea (Democratic) and CO2 emissions (% of total fuel combustion) in Mozambique?
Offer a terse response. -30.46. In the year 1985, what is the difference between the CO2 emissions (% of total fuel combustion) in Korea (Democratic) and CO2 emissions (% of total fuel combustion) in Syrian Arab Republic?
Offer a terse response. 6.6. In the year 1985, what is the difference between the CO2 emissions (% of total fuel combustion) of Mozambique and CO2 emissions (% of total fuel combustion) of Syrian Arab Republic?
Offer a very short reply. 37.07. What is the ratio of the CO2 emissions (% of total fuel combustion) in Haiti in 1978 to that in 1979?
Provide a short and direct response. 1.02. What is the ratio of the CO2 emissions (% of total fuel combustion) in Korea (Democratic) in 1978 to that in 1979?
Your answer should be compact. 1.04. What is the ratio of the CO2 emissions (% of total fuel combustion) of Mozambique in 1978 to that in 1979?
Make the answer very short. 0.92. What is the ratio of the CO2 emissions (% of total fuel combustion) of Syrian Arab Republic in 1978 to that in 1979?
Make the answer very short. 1.24. What is the ratio of the CO2 emissions (% of total fuel combustion) of Haiti in 1978 to that in 1980?
Keep it short and to the point. 0.95. What is the ratio of the CO2 emissions (% of total fuel combustion) of Korea (Democratic) in 1978 to that in 1980?
Offer a terse response. 1.03. What is the ratio of the CO2 emissions (% of total fuel combustion) of Mozambique in 1978 to that in 1980?
Offer a very short reply. 0.89. What is the ratio of the CO2 emissions (% of total fuel combustion) of Syrian Arab Republic in 1978 to that in 1980?
Provide a short and direct response. 1.03. What is the ratio of the CO2 emissions (% of total fuel combustion) in Haiti in 1978 to that in 1981?
Provide a succinct answer. 0.81. What is the ratio of the CO2 emissions (% of total fuel combustion) in Korea (Democratic) in 1978 to that in 1981?
Keep it short and to the point. 0.95. What is the ratio of the CO2 emissions (% of total fuel combustion) of Mozambique in 1978 to that in 1981?
Your answer should be very brief. 1.26. What is the ratio of the CO2 emissions (% of total fuel combustion) of Syrian Arab Republic in 1978 to that in 1981?
Ensure brevity in your answer.  1.03. What is the ratio of the CO2 emissions (% of total fuel combustion) of Haiti in 1978 to that in 1982?
Give a very brief answer. 1.03. What is the ratio of the CO2 emissions (% of total fuel combustion) of Korea (Democratic) in 1978 to that in 1982?
Keep it short and to the point. 0.99. What is the ratio of the CO2 emissions (% of total fuel combustion) in Mozambique in 1978 to that in 1982?
Keep it short and to the point. 1.1. What is the ratio of the CO2 emissions (% of total fuel combustion) in Syrian Arab Republic in 1978 to that in 1982?
Your answer should be very brief. 0.48. What is the ratio of the CO2 emissions (% of total fuel combustion) in Haiti in 1978 to that in 1983?
Provide a succinct answer. 1.16. What is the ratio of the CO2 emissions (% of total fuel combustion) of Korea (Democratic) in 1978 to that in 1983?
Your response must be concise. 0.98. What is the ratio of the CO2 emissions (% of total fuel combustion) of Mozambique in 1978 to that in 1983?
Make the answer very short. 0.8. What is the ratio of the CO2 emissions (% of total fuel combustion) in Syrian Arab Republic in 1978 to that in 1983?
Your answer should be very brief. 0.35. What is the ratio of the CO2 emissions (% of total fuel combustion) in Haiti in 1978 to that in 1984?
Give a very brief answer. 1.2. What is the ratio of the CO2 emissions (% of total fuel combustion) in Korea (Democratic) in 1978 to that in 1984?
Make the answer very short. 0.99. What is the ratio of the CO2 emissions (% of total fuel combustion) in Mozambique in 1978 to that in 1984?
Provide a succinct answer. 0.71. What is the ratio of the CO2 emissions (% of total fuel combustion) of Syrian Arab Republic in 1978 to that in 1984?
Your answer should be very brief. 0.3. What is the ratio of the CO2 emissions (% of total fuel combustion) in Haiti in 1978 to that in 1985?
Ensure brevity in your answer.  1.23. What is the ratio of the CO2 emissions (% of total fuel combustion) in Korea (Democratic) in 1978 to that in 1985?
Offer a very short reply. 0.97. What is the ratio of the CO2 emissions (% of total fuel combustion) in Mozambique in 1978 to that in 1985?
Make the answer very short. 0.53. What is the ratio of the CO2 emissions (% of total fuel combustion) of Syrian Arab Republic in 1978 to that in 1985?
Provide a succinct answer. 0.47. What is the ratio of the CO2 emissions (% of total fuel combustion) in Haiti in 1979 to that in 1980?
Ensure brevity in your answer.  0.94. What is the ratio of the CO2 emissions (% of total fuel combustion) in Mozambique in 1979 to that in 1980?
Keep it short and to the point. 0.97. What is the ratio of the CO2 emissions (% of total fuel combustion) of Syrian Arab Republic in 1979 to that in 1980?
Provide a succinct answer. 0.83. What is the ratio of the CO2 emissions (% of total fuel combustion) of Korea (Democratic) in 1979 to that in 1981?
Make the answer very short. 0.92. What is the ratio of the CO2 emissions (% of total fuel combustion) in Mozambique in 1979 to that in 1981?
Provide a succinct answer. 1.37. What is the ratio of the CO2 emissions (% of total fuel combustion) in Syrian Arab Republic in 1979 to that in 1981?
Offer a very short reply. 0.84. What is the ratio of the CO2 emissions (% of total fuel combustion) in Haiti in 1979 to that in 1982?
Offer a very short reply. 1.02. What is the ratio of the CO2 emissions (% of total fuel combustion) of Korea (Democratic) in 1979 to that in 1982?
Your response must be concise. 0.95. What is the ratio of the CO2 emissions (% of total fuel combustion) in Mozambique in 1979 to that in 1982?
Offer a very short reply. 1.19. What is the ratio of the CO2 emissions (% of total fuel combustion) of Syrian Arab Republic in 1979 to that in 1982?
Make the answer very short. 0.39. What is the ratio of the CO2 emissions (% of total fuel combustion) of Haiti in 1979 to that in 1983?
Provide a short and direct response. 1.14. What is the ratio of the CO2 emissions (% of total fuel combustion) in Korea (Democratic) in 1979 to that in 1983?
Offer a very short reply. 0.95. What is the ratio of the CO2 emissions (% of total fuel combustion) in Mozambique in 1979 to that in 1983?
Ensure brevity in your answer.  0.87. What is the ratio of the CO2 emissions (% of total fuel combustion) of Syrian Arab Republic in 1979 to that in 1983?
Ensure brevity in your answer.  0.28. What is the ratio of the CO2 emissions (% of total fuel combustion) of Haiti in 1979 to that in 1984?
Make the answer very short. 1.18. What is the ratio of the CO2 emissions (% of total fuel combustion) of Korea (Democratic) in 1979 to that in 1984?
Provide a short and direct response. 0.96. What is the ratio of the CO2 emissions (% of total fuel combustion) in Mozambique in 1979 to that in 1984?
Offer a terse response. 0.78. What is the ratio of the CO2 emissions (% of total fuel combustion) of Syrian Arab Republic in 1979 to that in 1984?
Offer a terse response. 0.25. What is the ratio of the CO2 emissions (% of total fuel combustion) of Haiti in 1979 to that in 1985?
Offer a terse response. 1.22. What is the ratio of the CO2 emissions (% of total fuel combustion) of Korea (Democratic) in 1979 to that in 1985?
Provide a short and direct response. 0.94. What is the ratio of the CO2 emissions (% of total fuel combustion) of Mozambique in 1979 to that in 1985?
Offer a terse response. 0.58. What is the ratio of the CO2 emissions (% of total fuel combustion) in Syrian Arab Republic in 1979 to that in 1985?
Your response must be concise. 0.38. What is the ratio of the CO2 emissions (% of total fuel combustion) in Haiti in 1980 to that in 1981?
Provide a succinct answer. 0.85. What is the ratio of the CO2 emissions (% of total fuel combustion) of Korea (Democratic) in 1980 to that in 1981?
Ensure brevity in your answer.  0.93. What is the ratio of the CO2 emissions (% of total fuel combustion) in Mozambique in 1980 to that in 1981?
Your answer should be compact. 1.41. What is the ratio of the CO2 emissions (% of total fuel combustion) of Syrian Arab Republic in 1980 to that in 1981?
Ensure brevity in your answer.  1.01. What is the ratio of the CO2 emissions (% of total fuel combustion) in Haiti in 1980 to that in 1982?
Keep it short and to the point. 1.08. What is the ratio of the CO2 emissions (% of total fuel combustion) in Korea (Democratic) in 1980 to that in 1982?
Provide a short and direct response. 0.96. What is the ratio of the CO2 emissions (% of total fuel combustion) in Mozambique in 1980 to that in 1982?
Your answer should be compact. 1.23. What is the ratio of the CO2 emissions (% of total fuel combustion) in Syrian Arab Republic in 1980 to that in 1982?
Your response must be concise. 0.47. What is the ratio of the CO2 emissions (% of total fuel combustion) of Haiti in 1980 to that in 1983?
Your answer should be very brief. 1.21. What is the ratio of the CO2 emissions (% of total fuel combustion) of Korea (Democratic) in 1980 to that in 1983?
Offer a terse response. 0.96. What is the ratio of the CO2 emissions (% of total fuel combustion) of Mozambique in 1980 to that in 1983?
Make the answer very short. 0.9. What is the ratio of the CO2 emissions (% of total fuel combustion) of Syrian Arab Republic in 1980 to that in 1983?
Your answer should be very brief. 0.34. What is the ratio of the CO2 emissions (% of total fuel combustion) of Haiti in 1980 to that in 1984?
Offer a very short reply. 1.26. What is the ratio of the CO2 emissions (% of total fuel combustion) in Korea (Democratic) in 1980 to that in 1984?
Provide a succinct answer. 0.96. What is the ratio of the CO2 emissions (% of total fuel combustion) of Mozambique in 1980 to that in 1984?
Provide a short and direct response. 0.8. What is the ratio of the CO2 emissions (% of total fuel combustion) in Syrian Arab Republic in 1980 to that in 1984?
Give a very brief answer. 0.3. What is the ratio of the CO2 emissions (% of total fuel combustion) in Haiti in 1980 to that in 1985?
Your answer should be very brief. 1.3. What is the ratio of the CO2 emissions (% of total fuel combustion) of Korea (Democratic) in 1980 to that in 1985?
Your answer should be compact. 0.94. What is the ratio of the CO2 emissions (% of total fuel combustion) of Mozambique in 1980 to that in 1985?
Offer a very short reply. 0.6. What is the ratio of the CO2 emissions (% of total fuel combustion) in Syrian Arab Republic in 1980 to that in 1985?
Ensure brevity in your answer.  0.46. What is the ratio of the CO2 emissions (% of total fuel combustion) of Haiti in 1981 to that in 1982?
Your answer should be very brief. 1.27. What is the ratio of the CO2 emissions (% of total fuel combustion) of Korea (Democratic) in 1981 to that in 1982?
Provide a succinct answer. 1.04. What is the ratio of the CO2 emissions (% of total fuel combustion) of Mozambique in 1981 to that in 1982?
Your answer should be very brief. 0.87. What is the ratio of the CO2 emissions (% of total fuel combustion) of Syrian Arab Republic in 1981 to that in 1982?
Provide a succinct answer. 0.46. What is the ratio of the CO2 emissions (% of total fuel combustion) in Haiti in 1981 to that in 1983?
Offer a very short reply. 1.42. What is the ratio of the CO2 emissions (% of total fuel combustion) in Korea (Democratic) in 1981 to that in 1983?
Provide a succinct answer. 1.03. What is the ratio of the CO2 emissions (% of total fuel combustion) of Mozambique in 1981 to that in 1983?
Ensure brevity in your answer.  0.64. What is the ratio of the CO2 emissions (% of total fuel combustion) in Syrian Arab Republic in 1981 to that in 1983?
Offer a terse response. 0.34. What is the ratio of the CO2 emissions (% of total fuel combustion) of Haiti in 1981 to that in 1984?
Provide a short and direct response. 1.48. What is the ratio of the CO2 emissions (% of total fuel combustion) of Korea (Democratic) in 1981 to that in 1984?
Offer a terse response. 1.04. What is the ratio of the CO2 emissions (% of total fuel combustion) of Mozambique in 1981 to that in 1984?
Your answer should be very brief. 0.57. What is the ratio of the CO2 emissions (% of total fuel combustion) of Syrian Arab Republic in 1981 to that in 1984?
Ensure brevity in your answer.  0.29. What is the ratio of the CO2 emissions (% of total fuel combustion) of Haiti in 1981 to that in 1985?
Your response must be concise. 1.52. What is the ratio of the CO2 emissions (% of total fuel combustion) in Korea (Democratic) in 1981 to that in 1985?
Keep it short and to the point. 1.02. What is the ratio of the CO2 emissions (% of total fuel combustion) in Mozambique in 1981 to that in 1985?
Keep it short and to the point. 0.42. What is the ratio of the CO2 emissions (% of total fuel combustion) in Syrian Arab Republic in 1981 to that in 1985?
Give a very brief answer. 0.46. What is the ratio of the CO2 emissions (% of total fuel combustion) in Haiti in 1982 to that in 1983?
Keep it short and to the point. 1.12. What is the ratio of the CO2 emissions (% of total fuel combustion) of Korea (Democratic) in 1982 to that in 1983?
Your answer should be very brief. 1. What is the ratio of the CO2 emissions (% of total fuel combustion) of Mozambique in 1982 to that in 1983?
Keep it short and to the point. 0.73. What is the ratio of the CO2 emissions (% of total fuel combustion) of Syrian Arab Republic in 1982 to that in 1983?
Make the answer very short. 0.73. What is the ratio of the CO2 emissions (% of total fuel combustion) in Haiti in 1982 to that in 1984?
Provide a succinct answer. 1.17. What is the ratio of the CO2 emissions (% of total fuel combustion) in Korea (Democratic) in 1982 to that in 1984?
Your answer should be compact. 1. What is the ratio of the CO2 emissions (% of total fuel combustion) of Mozambique in 1982 to that in 1984?
Your response must be concise. 0.65. What is the ratio of the CO2 emissions (% of total fuel combustion) in Syrian Arab Republic in 1982 to that in 1984?
Provide a short and direct response. 0.63. What is the ratio of the CO2 emissions (% of total fuel combustion) of Haiti in 1982 to that in 1985?
Offer a very short reply. 1.2. What is the ratio of the CO2 emissions (% of total fuel combustion) in Korea (Democratic) in 1982 to that in 1985?
Keep it short and to the point. 0.98. What is the ratio of the CO2 emissions (% of total fuel combustion) of Mozambique in 1982 to that in 1985?
Offer a terse response. 0.49. What is the ratio of the CO2 emissions (% of total fuel combustion) of Haiti in 1983 to that in 1984?
Offer a terse response. 1.04. What is the ratio of the CO2 emissions (% of total fuel combustion) of Mozambique in 1983 to that in 1984?
Offer a terse response. 0.89. What is the ratio of the CO2 emissions (% of total fuel combustion) in Syrian Arab Republic in 1983 to that in 1984?
Provide a succinct answer. 0.86. What is the ratio of the CO2 emissions (% of total fuel combustion) of Haiti in 1983 to that in 1985?
Your response must be concise. 1.07. What is the ratio of the CO2 emissions (% of total fuel combustion) in Korea (Democratic) in 1983 to that in 1985?
Your answer should be very brief. 0.98. What is the ratio of the CO2 emissions (% of total fuel combustion) of Mozambique in 1983 to that in 1985?
Ensure brevity in your answer.  0.66. What is the ratio of the CO2 emissions (% of total fuel combustion) in Syrian Arab Republic in 1983 to that in 1985?
Ensure brevity in your answer.  1.35. What is the ratio of the CO2 emissions (% of total fuel combustion) of Korea (Democratic) in 1984 to that in 1985?
Your answer should be compact. 0.98. What is the ratio of the CO2 emissions (% of total fuel combustion) in Mozambique in 1984 to that in 1985?
Offer a very short reply. 0.75. What is the ratio of the CO2 emissions (% of total fuel combustion) in Syrian Arab Republic in 1984 to that in 1985?
Provide a short and direct response. 1.56. What is the difference between the highest and the second highest CO2 emissions (% of total fuel combustion) in Haiti?
Keep it short and to the point. 0.28. What is the difference between the highest and the second highest CO2 emissions (% of total fuel combustion) in Korea (Democratic)?
Provide a short and direct response. 0.28. What is the difference between the highest and the second highest CO2 emissions (% of total fuel combustion) in Mozambique?
Keep it short and to the point. 11.81. What is the difference between the highest and the second highest CO2 emissions (% of total fuel combustion) of Syrian Arab Republic?
Provide a succinct answer. 2.09. What is the difference between the highest and the lowest CO2 emissions (% of total fuel combustion) of Haiti?
Your response must be concise. 0.66. What is the difference between the highest and the lowest CO2 emissions (% of total fuel combustion) in Korea (Democratic)?
Make the answer very short. 1.36. What is the difference between the highest and the lowest CO2 emissions (% of total fuel combustion) in Mozambique?
Ensure brevity in your answer.  27.08. What is the difference between the highest and the lowest CO2 emissions (% of total fuel combustion) in Syrian Arab Republic?
Provide a succinct answer. 11.65. 